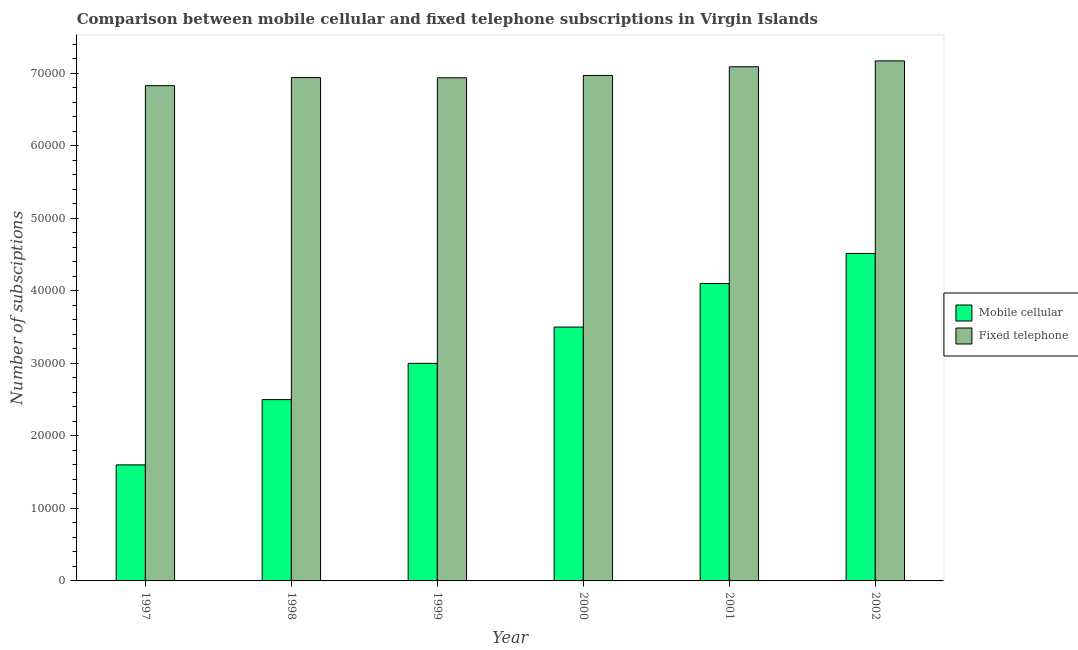Are the number of bars on each tick of the X-axis equal?
Keep it short and to the point. Yes. What is the number of fixed telephone subscriptions in 2002?
Offer a terse response. 7.17e+04. Across all years, what is the maximum number of fixed telephone subscriptions?
Your answer should be compact. 7.17e+04. Across all years, what is the minimum number of mobile cellular subscriptions?
Keep it short and to the point. 1.60e+04. In which year was the number of fixed telephone subscriptions maximum?
Your response must be concise. 2002. In which year was the number of mobile cellular subscriptions minimum?
Give a very brief answer. 1997. What is the total number of fixed telephone subscriptions in the graph?
Your answer should be very brief. 4.19e+05. What is the difference between the number of mobile cellular subscriptions in 1997 and that in 2001?
Provide a succinct answer. -2.50e+04. What is the difference between the number of fixed telephone subscriptions in 2000 and the number of mobile cellular subscriptions in 1998?
Offer a terse response. 291. What is the average number of fixed telephone subscriptions per year?
Provide a short and direct response. 6.99e+04. What is the ratio of the number of fixed telephone subscriptions in 1998 to that in 2001?
Offer a terse response. 0.98. What is the difference between the highest and the second highest number of fixed telephone subscriptions?
Make the answer very short. 812. What is the difference between the highest and the lowest number of mobile cellular subscriptions?
Keep it short and to the point. 2.92e+04. What does the 2nd bar from the left in 2000 represents?
Offer a very short reply. Fixed telephone. What does the 1st bar from the right in 2001 represents?
Your answer should be compact. Fixed telephone. Does the graph contain any zero values?
Your response must be concise. No. Does the graph contain grids?
Offer a very short reply. No. How many legend labels are there?
Offer a very short reply. 2. What is the title of the graph?
Give a very brief answer. Comparison between mobile cellular and fixed telephone subscriptions in Virgin Islands. Does "Female" appear as one of the legend labels in the graph?
Provide a succinct answer. No. What is the label or title of the X-axis?
Your response must be concise. Year. What is the label or title of the Y-axis?
Provide a short and direct response. Number of subsciptions. What is the Number of subsciptions in Mobile cellular in 1997?
Provide a succinct answer. 1.60e+04. What is the Number of subsciptions in Fixed telephone in 1997?
Give a very brief answer. 6.83e+04. What is the Number of subsciptions of Mobile cellular in 1998?
Offer a terse response. 2.50e+04. What is the Number of subsciptions in Fixed telephone in 1998?
Your answer should be very brief. 6.94e+04. What is the Number of subsciptions of Fixed telephone in 1999?
Offer a very short reply. 6.94e+04. What is the Number of subsciptions in Mobile cellular in 2000?
Your response must be concise. 3.50e+04. What is the Number of subsciptions of Fixed telephone in 2000?
Give a very brief answer. 6.97e+04. What is the Number of subsciptions in Mobile cellular in 2001?
Give a very brief answer. 4.10e+04. What is the Number of subsciptions in Fixed telephone in 2001?
Provide a short and direct response. 7.09e+04. What is the Number of subsciptions of Mobile cellular in 2002?
Provide a short and direct response. 4.52e+04. What is the Number of subsciptions in Fixed telephone in 2002?
Offer a very short reply. 7.17e+04. Across all years, what is the maximum Number of subsciptions of Mobile cellular?
Provide a succinct answer. 4.52e+04. Across all years, what is the maximum Number of subsciptions of Fixed telephone?
Provide a short and direct response. 7.17e+04. Across all years, what is the minimum Number of subsciptions of Mobile cellular?
Your answer should be compact. 1.60e+04. Across all years, what is the minimum Number of subsciptions in Fixed telephone?
Provide a succinct answer. 6.83e+04. What is the total Number of subsciptions of Mobile cellular in the graph?
Offer a terse response. 1.92e+05. What is the total Number of subsciptions in Fixed telephone in the graph?
Provide a succinct answer. 4.19e+05. What is the difference between the Number of subsciptions of Mobile cellular in 1997 and that in 1998?
Ensure brevity in your answer.  -9000. What is the difference between the Number of subsciptions of Fixed telephone in 1997 and that in 1998?
Provide a succinct answer. -1117. What is the difference between the Number of subsciptions in Mobile cellular in 1997 and that in 1999?
Ensure brevity in your answer.  -1.40e+04. What is the difference between the Number of subsciptions in Fixed telephone in 1997 and that in 1999?
Give a very brief answer. -1086. What is the difference between the Number of subsciptions in Mobile cellular in 1997 and that in 2000?
Provide a succinct answer. -1.90e+04. What is the difference between the Number of subsciptions in Fixed telephone in 1997 and that in 2000?
Provide a succinct answer. -1408. What is the difference between the Number of subsciptions in Mobile cellular in 1997 and that in 2001?
Provide a short and direct response. -2.50e+04. What is the difference between the Number of subsciptions in Fixed telephone in 1997 and that in 2001?
Make the answer very short. -2605. What is the difference between the Number of subsciptions in Mobile cellular in 1997 and that in 2002?
Keep it short and to the point. -2.92e+04. What is the difference between the Number of subsciptions in Fixed telephone in 1997 and that in 2002?
Provide a short and direct response. -3417. What is the difference between the Number of subsciptions in Mobile cellular in 1998 and that in 1999?
Ensure brevity in your answer.  -5000. What is the difference between the Number of subsciptions in Fixed telephone in 1998 and that in 1999?
Offer a terse response. 31. What is the difference between the Number of subsciptions in Fixed telephone in 1998 and that in 2000?
Provide a short and direct response. -291. What is the difference between the Number of subsciptions in Mobile cellular in 1998 and that in 2001?
Keep it short and to the point. -1.60e+04. What is the difference between the Number of subsciptions in Fixed telephone in 1998 and that in 2001?
Offer a terse response. -1488. What is the difference between the Number of subsciptions of Mobile cellular in 1998 and that in 2002?
Keep it short and to the point. -2.02e+04. What is the difference between the Number of subsciptions in Fixed telephone in 1998 and that in 2002?
Keep it short and to the point. -2300. What is the difference between the Number of subsciptions in Mobile cellular in 1999 and that in 2000?
Keep it short and to the point. -5000. What is the difference between the Number of subsciptions in Fixed telephone in 1999 and that in 2000?
Your answer should be compact. -322. What is the difference between the Number of subsciptions in Mobile cellular in 1999 and that in 2001?
Provide a short and direct response. -1.10e+04. What is the difference between the Number of subsciptions in Fixed telephone in 1999 and that in 2001?
Your response must be concise. -1519. What is the difference between the Number of subsciptions of Mobile cellular in 1999 and that in 2002?
Your response must be concise. -1.52e+04. What is the difference between the Number of subsciptions in Fixed telephone in 1999 and that in 2002?
Make the answer very short. -2331. What is the difference between the Number of subsciptions of Mobile cellular in 2000 and that in 2001?
Ensure brevity in your answer.  -6000. What is the difference between the Number of subsciptions in Fixed telephone in 2000 and that in 2001?
Provide a succinct answer. -1197. What is the difference between the Number of subsciptions of Mobile cellular in 2000 and that in 2002?
Make the answer very short. -1.02e+04. What is the difference between the Number of subsciptions in Fixed telephone in 2000 and that in 2002?
Provide a succinct answer. -2009. What is the difference between the Number of subsciptions in Mobile cellular in 2001 and that in 2002?
Keep it short and to the point. -4150. What is the difference between the Number of subsciptions of Fixed telephone in 2001 and that in 2002?
Offer a very short reply. -812. What is the difference between the Number of subsciptions of Mobile cellular in 1997 and the Number of subsciptions of Fixed telephone in 1998?
Provide a short and direct response. -5.34e+04. What is the difference between the Number of subsciptions in Mobile cellular in 1997 and the Number of subsciptions in Fixed telephone in 1999?
Your answer should be compact. -5.34e+04. What is the difference between the Number of subsciptions of Mobile cellular in 1997 and the Number of subsciptions of Fixed telephone in 2000?
Your answer should be compact. -5.37e+04. What is the difference between the Number of subsciptions in Mobile cellular in 1997 and the Number of subsciptions in Fixed telephone in 2001?
Offer a terse response. -5.49e+04. What is the difference between the Number of subsciptions of Mobile cellular in 1997 and the Number of subsciptions of Fixed telephone in 2002?
Make the answer very short. -5.57e+04. What is the difference between the Number of subsciptions of Mobile cellular in 1998 and the Number of subsciptions of Fixed telephone in 1999?
Provide a short and direct response. -4.44e+04. What is the difference between the Number of subsciptions of Mobile cellular in 1998 and the Number of subsciptions of Fixed telephone in 2000?
Provide a short and direct response. -4.47e+04. What is the difference between the Number of subsciptions in Mobile cellular in 1998 and the Number of subsciptions in Fixed telephone in 2001?
Give a very brief answer. -4.59e+04. What is the difference between the Number of subsciptions of Mobile cellular in 1998 and the Number of subsciptions of Fixed telephone in 2002?
Provide a succinct answer. -4.67e+04. What is the difference between the Number of subsciptions of Mobile cellular in 1999 and the Number of subsciptions of Fixed telephone in 2000?
Your answer should be very brief. -3.97e+04. What is the difference between the Number of subsciptions in Mobile cellular in 1999 and the Number of subsciptions in Fixed telephone in 2001?
Give a very brief answer. -4.09e+04. What is the difference between the Number of subsciptions in Mobile cellular in 1999 and the Number of subsciptions in Fixed telephone in 2002?
Your answer should be very brief. -4.17e+04. What is the difference between the Number of subsciptions in Mobile cellular in 2000 and the Number of subsciptions in Fixed telephone in 2001?
Your answer should be compact. -3.59e+04. What is the difference between the Number of subsciptions in Mobile cellular in 2000 and the Number of subsciptions in Fixed telephone in 2002?
Keep it short and to the point. -3.67e+04. What is the difference between the Number of subsciptions in Mobile cellular in 2001 and the Number of subsciptions in Fixed telephone in 2002?
Provide a succinct answer. -3.07e+04. What is the average Number of subsciptions of Mobile cellular per year?
Keep it short and to the point. 3.20e+04. What is the average Number of subsciptions in Fixed telephone per year?
Your answer should be very brief. 6.99e+04. In the year 1997, what is the difference between the Number of subsciptions of Mobile cellular and Number of subsciptions of Fixed telephone?
Your answer should be compact. -5.23e+04. In the year 1998, what is the difference between the Number of subsciptions in Mobile cellular and Number of subsciptions in Fixed telephone?
Give a very brief answer. -4.44e+04. In the year 1999, what is the difference between the Number of subsciptions in Mobile cellular and Number of subsciptions in Fixed telephone?
Offer a terse response. -3.94e+04. In the year 2000, what is the difference between the Number of subsciptions of Mobile cellular and Number of subsciptions of Fixed telephone?
Ensure brevity in your answer.  -3.47e+04. In the year 2001, what is the difference between the Number of subsciptions in Mobile cellular and Number of subsciptions in Fixed telephone?
Your response must be concise. -2.99e+04. In the year 2002, what is the difference between the Number of subsciptions of Mobile cellular and Number of subsciptions of Fixed telephone?
Give a very brief answer. -2.66e+04. What is the ratio of the Number of subsciptions in Mobile cellular in 1997 to that in 1998?
Keep it short and to the point. 0.64. What is the ratio of the Number of subsciptions in Fixed telephone in 1997 to that in 1998?
Provide a short and direct response. 0.98. What is the ratio of the Number of subsciptions of Mobile cellular in 1997 to that in 1999?
Ensure brevity in your answer.  0.53. What is the ratio of the Number of subsciptions of Fixed telephone in 1997 to that in 1999?
Your response must be concise. 0.98. What is the ratio of the Number of subsciptions in Mobile cellular in 1997 to that in 2000?
Your answer should be compact. 0.46. What is the ratio of the Number of subsciptions in Fixed telephone in 1997 to that in 2000?
Make the answer very short. 0.98. What is the ratio of the Number of subsciptions of Mobile cellular in 1997 to that in 2001?
Offer a terse response. 0.39. What is the ratio of the Number of subsciptions of Fixed telephone in 1997 to that in 2001?
Ensure brevity in your answer.  0.96. What is the ratio of the Number of subsciptions in Mobile cellular in 1997 to that in 2002?
Provide a succinct answer. 0.35. What is the ratio of the Number of subsciptions in Fixed telephone in 1997 to that in 2002?
Make the answer very short. 0.95. What is the ratio of the Number of subsciptions of Mobile cellular in 1998 to that in 1999?
Make the answer very short. 0.83. What is the ratio of the Number of subsciptions of Fixed telephone in 1998 to that in 1999?
Your answer should be very brief. 1. What is the ratio of the Number of subsciptions in Mobile cellular in 1998 to that in 2001?
Offer a terse response. 0.61. What is the ratio of the Number of subsciptions in Mobile cellular in 1998 to that in 2002?
Your answer should be very brief. 0.55. What is the ratio of the Number of subsciptions of Fixed telephone in 1998 to that in 2002?
Provide a succinct answer. 0.97. What is the ratio of the Number of subsciptions in Mobile cellular in 1999 to that in 2000?
Keep it short and to the point. 0.86. What is the ratio of the Number of subsciptions of Fixed telephone in 1999 to that in 2000?
Make the answer very short. 1. What is the ratio of the Number of subsciptions of Mobile cellular in 1999 to that in 2001?
Give a very brief answer. 0.73. What is the ratio of the Number of subsciptions of Fixed telephone in 1999 to that in 2001?
Provide a short and direct response. 0.98. What is the ratio of the Number of subsciptions in Mobile cellular in 1999 to that in 2002?
Your answer should be compact. 0.66. What is the ratio of the Number of subsciptions in Fixed telephone in 1999 to that in 2002?
Make the answer very short. 0.97. What is the ratio of the Number of subsciptions of Mobile cellular in 2000 to that in 2001?
Give a very brief answer. 0.85. What is the ratio of the Number of subsciptions of Fixed telephone in 2000 to that in 2001?
Give a very brief answer. 0.98. What is the ratio of the Number of subsciptions of Mobile cellular in 2000 to that in 2002?
Your response must be concise. 0.78. What is the ratio of the Number of subsciptions of Mobile cellular in 2001 to that in 2002?
Provide a succinct answer. 0.91. What is the ratio of the Number of subsciptions in Fixed telephone in 2001 to that in 2002?
Your answer should be very brief. 0.99. What is the difference between the highest and the second highest Number of subsciptions of Mobile cellular?
Give a very brief answer. 4150. What is the difference between the highest and the second highest Number of subsciptions of Fixed telephone?
Your response must be concise. 812. What is the difference between the highest and the lowest Number of subsciptions in Mobile cellular?
Provide a short and direct response. 2.92e+04. What is the difference between the highest and the lowest Number of subsciptions in Fixed telephone?
Provide a succinct answer. 3417. 